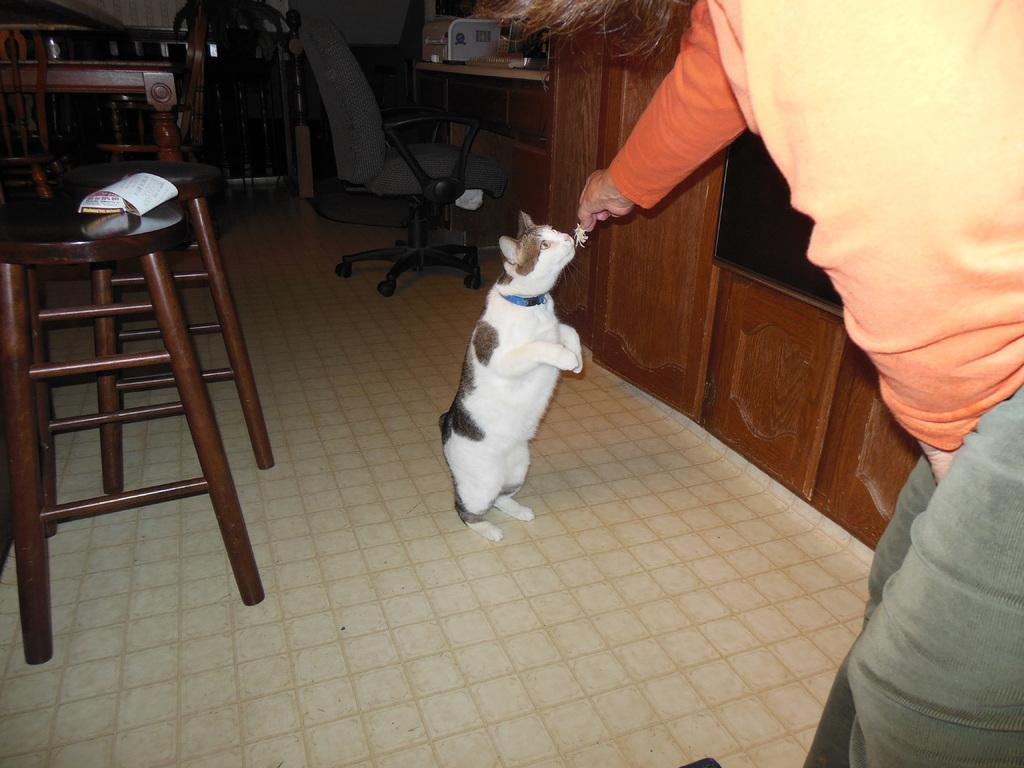Who or what is present in the image? There is a person and a cat in the image. What type of furniture can be seen in the room? There is a stool, a chair, and a table in the room. In which direction is the person facing in the image? The provided facts do not specify the direction the person is facing, so it cannot be determined from the image. 